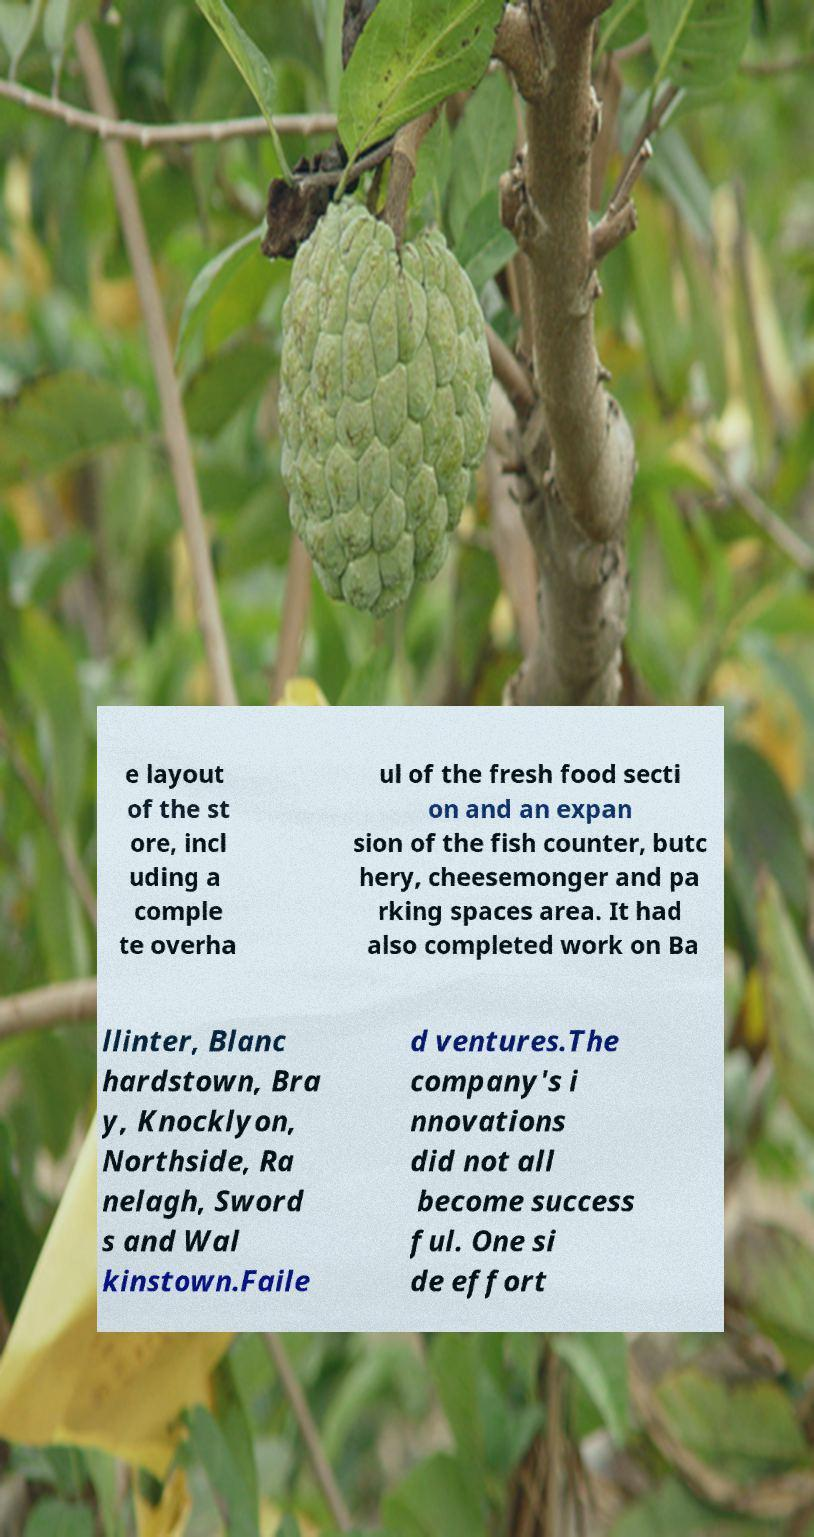For documentation purposes, I need the text within this image transcribed. Could you provide that? e layout of the st ore, incl uding a comple te overha ul of the fresh food secti on and an expan sion of the fish counter, butc hery, cheesemonger and pa rking spaces area. It had also completed work on Ba llinter, Blanc hardstown, Bra y, Knocklyon, Northside, Ra nelagh, Sword s and Wal kinstown.Faile d ventures.The company's i nnovations did not all become success ful. One si de effort 